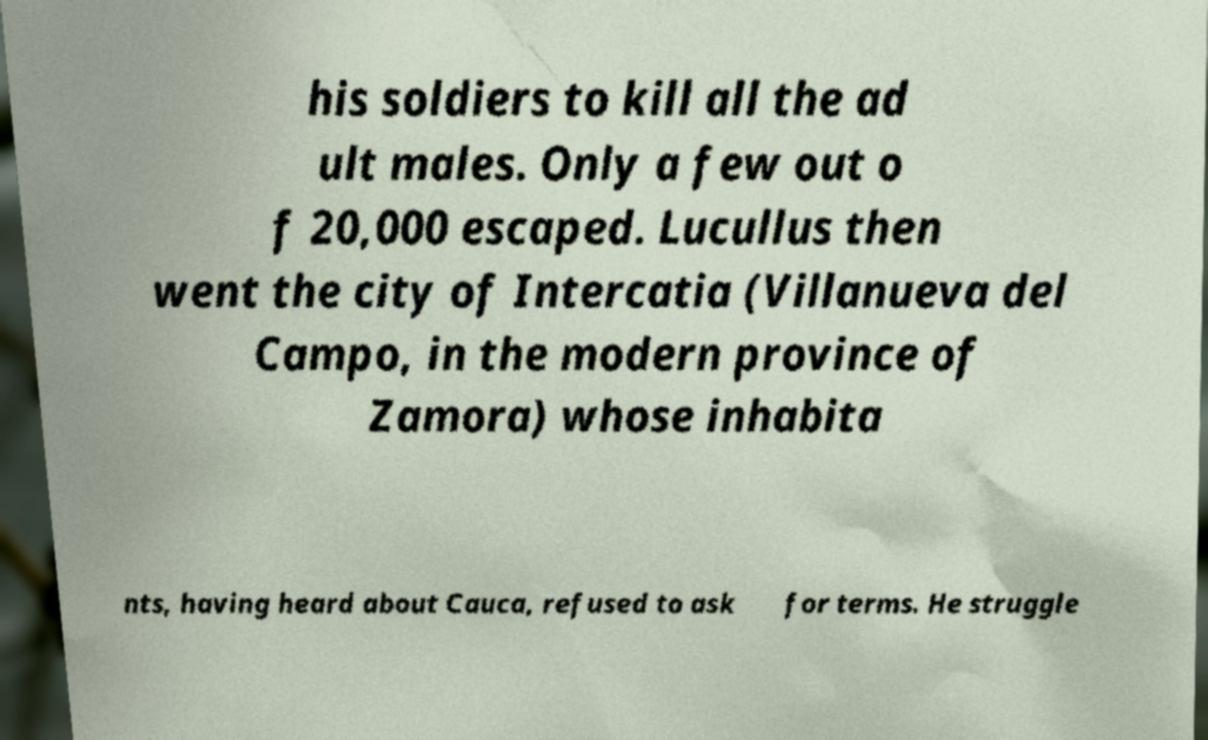Can you read and provide the text displayed in the image?This photo seems to have some interesting text. Can you extract and type it out for me? his soldiers to kill all the ad ult males. Only a few out o f 20,000 escaped. Lucullus then went the city of Intercatia (Villanueva del Campo, in the modern province of Zamora) whose inhabita nts, having heard about Cauca, refused to ask for terms. He struggle 